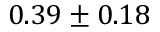<formula> <loc_0><loc_0><loc_500><loc_500>0 . 3 9 \pm 0 . 1 8</formula> 